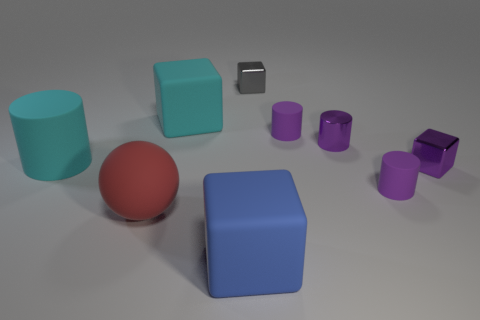What might be the purpose or concept behind the placement of objects in this image? This image can be interpreted in several ways. It might be an artistic composition, carefully crafted to explore geometric forms, colors, and materials, creating a visually appealing arrangement. Alternatively, it could represent a simple spatial reasoning test, possibly used in cognitive psychology to assess someone's ability to perceive and analyze spatial relationships between objects. Lastly, it could merely be a random assortment of 3D rendered objects, intended to demonstrate various textures and shapes without any deeper underlying purpose. 